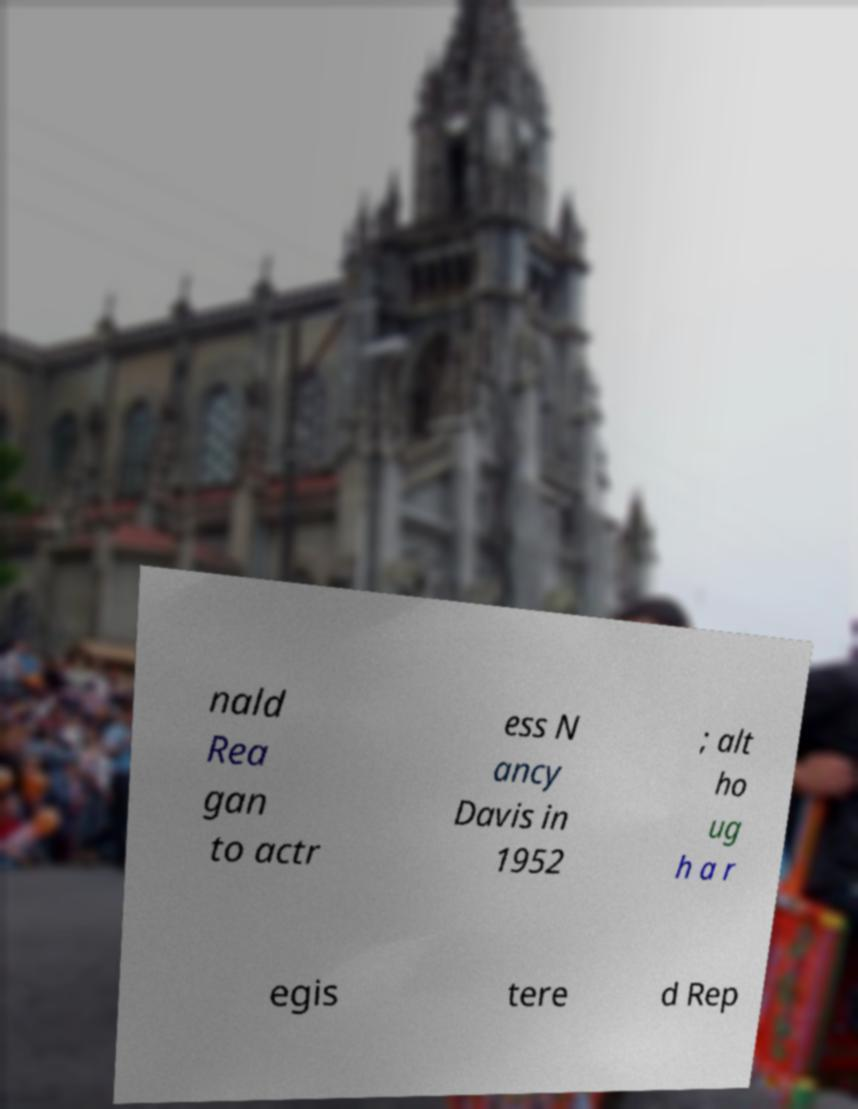For documentation purposes, I need the text within this image transcribed. Could you provide that? nald Rea gan to actr ess N ancy Davis in 1952 ; alt ho ug h a r egis tere d Rep 